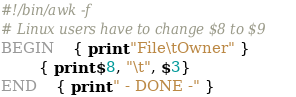Convert code to text. <code><loc_0><loc_0><loc_500><loc_500><_Awk_>#!/bin/awk -f
# Linux users have to change $8 to $9
BEGIN 	{ print "File\tOwner" }
		{ print $8, "\t", $3}
END   	{ print " - DONE -" }
</code> 